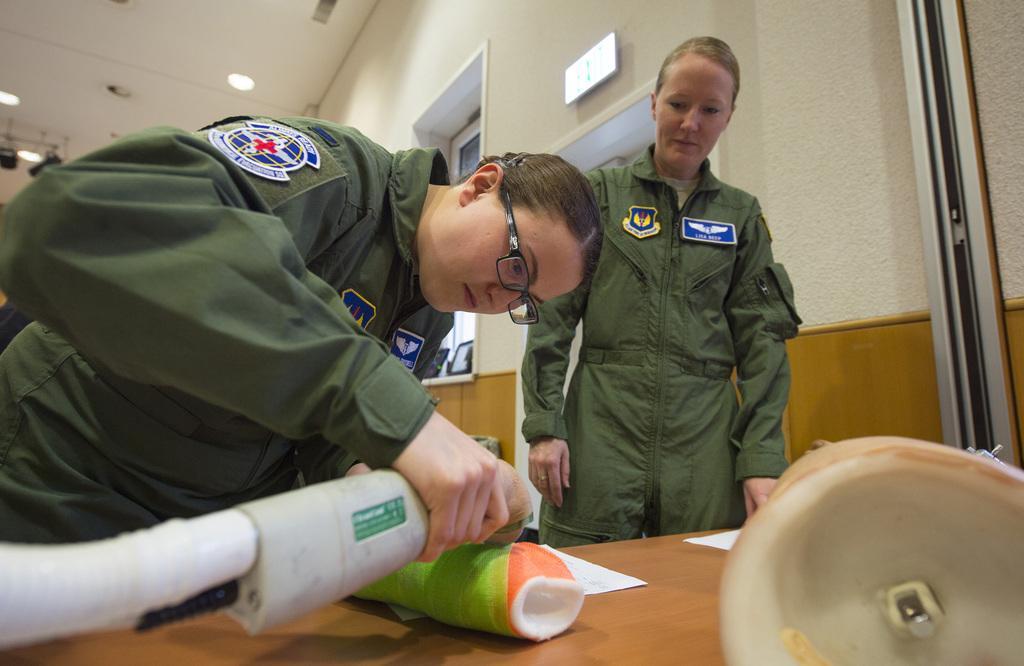In one or two sentences, can you explain what this image depicts? In front of the image there is a table. On top of it there are some objects. Behind the table there is a person holding some object. Beside her there is another person standing. In the background of the image there is a display board on the wall. There is a glass window. There are some objects on the platform. On top of the image there are lights. 